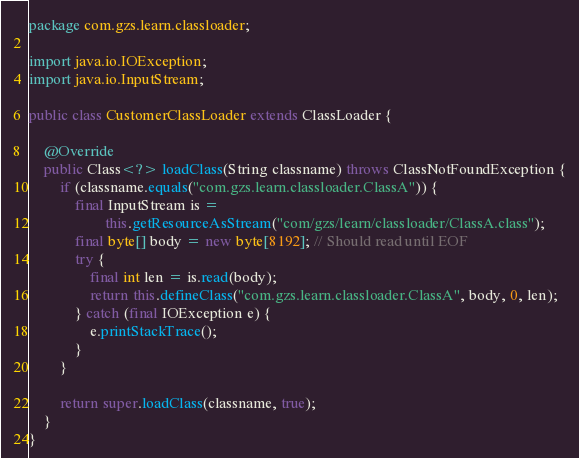<code> <loc_0><loc_0><loc_500><loc_500><_Java_>package com.gzs.learn.classloader;

import java.io.IOException;
import java.io.InputStream;

public class CustomerClassLoader extends ClassLoader {

    @Override
    public Class<?> loadClass(String classname) throws ClassNotFoundException {
        if (classname.equals("com.gzs.learn.classloader.ClassA")) {
            final InputStream is =
                    this.getResourceAsStream("com/gzs/learn/classloader/ClassA.class");
            final byte[] body = new byte[8192]; // Should read until EOF
            try {
                final int len = is.read(body);
                return this.defineClass("com.gzs.learn.classloader.ClassA", body, 0, len);
            } catch (final IOException e) {
                e.printStackTrace();
            }
        }

        return super.loadClass(classname, true);
    }
}
</code> 